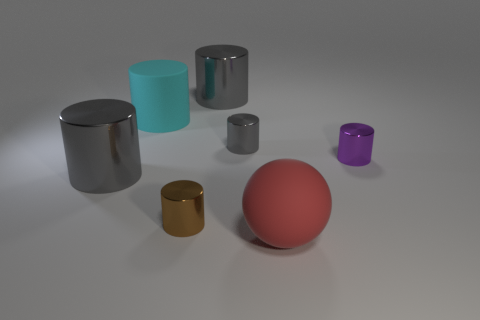Subtract all cyan balls. How many gray cylinders are left? 3 Subtract all purple metallic cylinders. How many cylinders are left? 5 Subtract all brown cylinders. How many cylinders are left? 5 Subtract 3 cylinders. How many cylinders are left? 3 Add 2 brown rubber blocks. How many objects exist? 9 Subtract all purple cylinders. Subtract all red balls. How many cylinders are left? 5 Subtract all balls. How many objects are left? 6 Add 7 tiny gray shiny things. How many tiny gray shiny things are left? 8 Add 2 large matte things. How many large matte things exist? 4 Subtract 1 cyan cylinders. How many objects are left? 6 